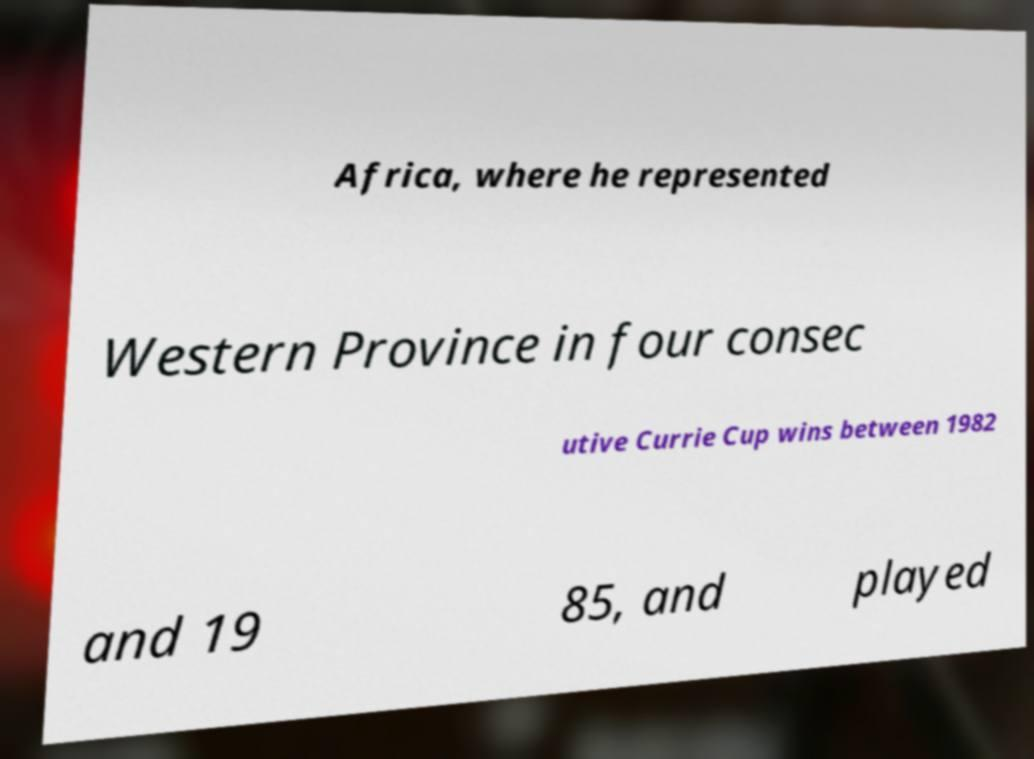Can you read and provide the text displayed in the image?This photo seems to have some interesting text. Can you extract and type it out for me? Africa, where he represented Western Province in four consec utive Currie Cup wins between 1982 and 19 85, and played 